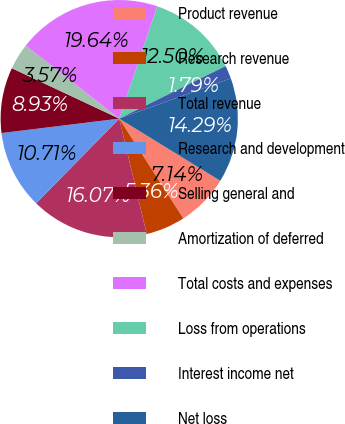Convert chart to OTSL. <chart><loc_0><loc_0><loc_500><loc_500><pie_chart><fcel>Product revenue<fcel>Research revenue<fcel>Total revenue<fcel>Research and development<fcel>Selling general and<fcel>Amortization of deferred<fcel>Total costs and expenses<fcel>Loss from operations<fcel>Interest income net<fcel>Net loss<nl><fcel>7.14%<fcel>5.36%<fcel>16.07%<fcel>10.71%<fcel>8.93%<fcel>3.57%<fcel>19.64%<fcel>12.5%<fcel>1.79%<fcel>14.29%<nl></chart> 